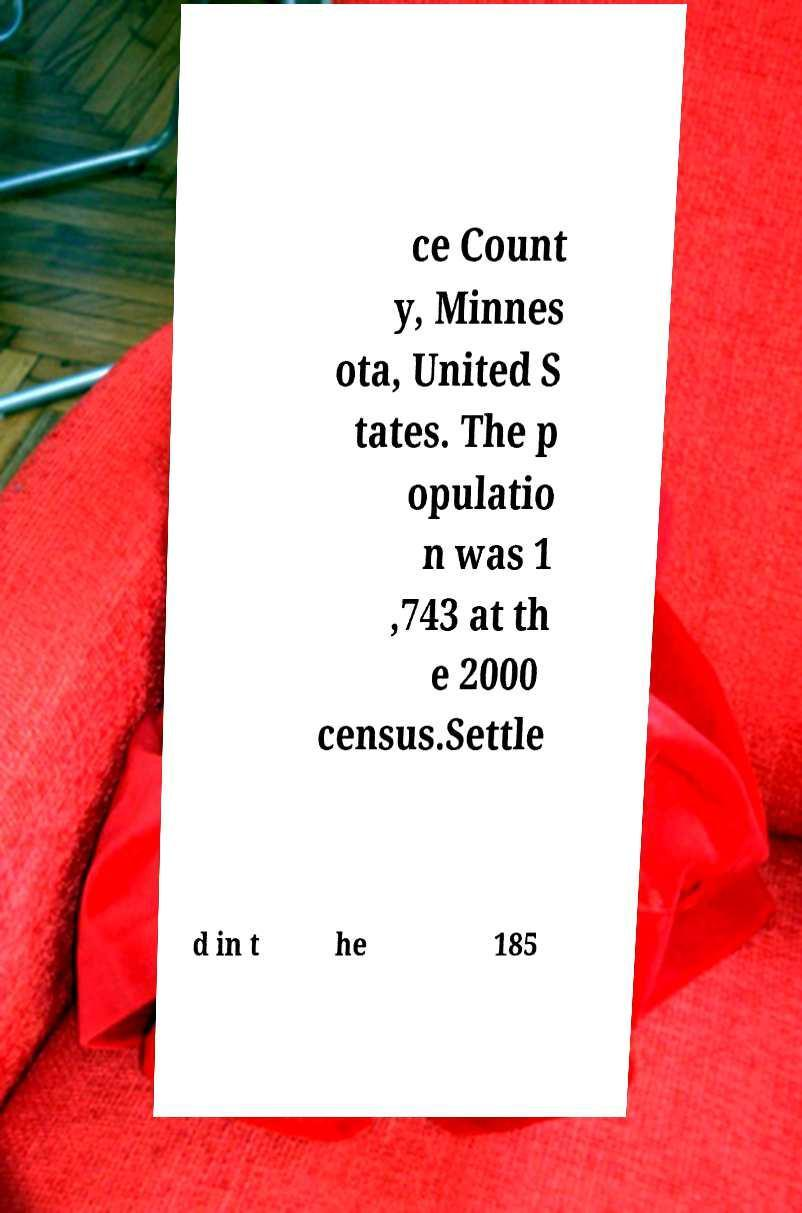Please identify and transcribe the text found in this image. ce Count y, Minnes ota, United S tates. The p opulatio n was 1 ,743 at th e 2000 census.Settle d in t he 185 